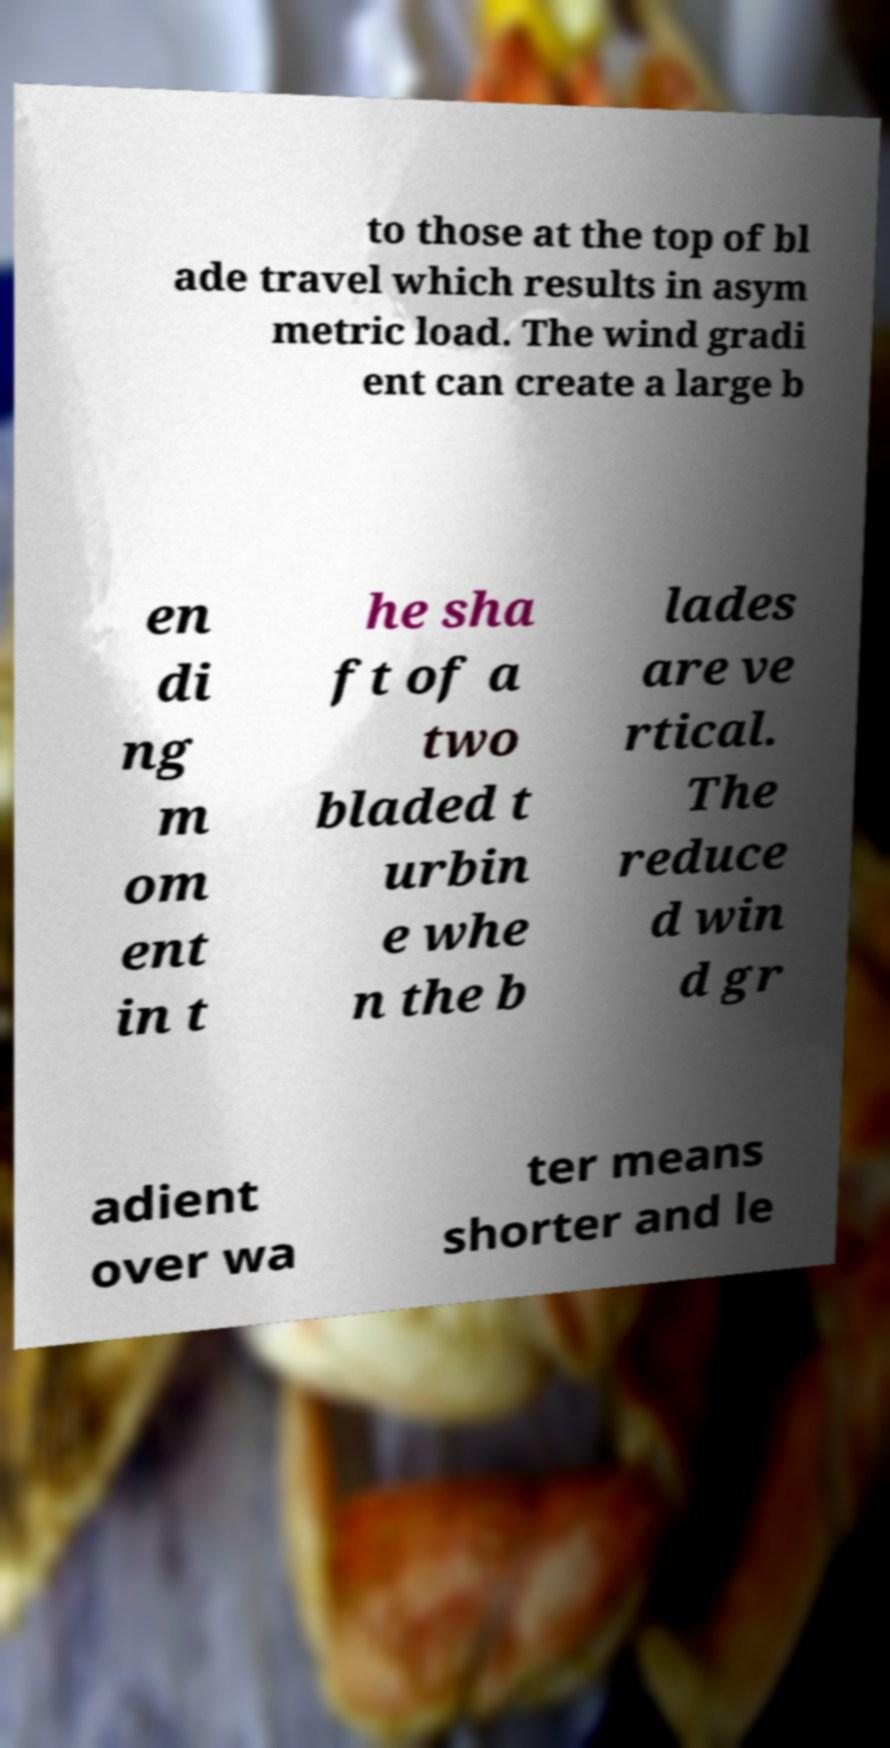There's text embedded in this image that I need extracted. Can you transcribe it verbatim? to those at the top of bl ade travel which results in asym metric load. The wind gradi ent can create a large b en di ng m om ent in t he sha ft of a two bladed t urbin e whe n the b lades are ve rtical. The reduce d win d gr adient over wa ter means shorter and le 